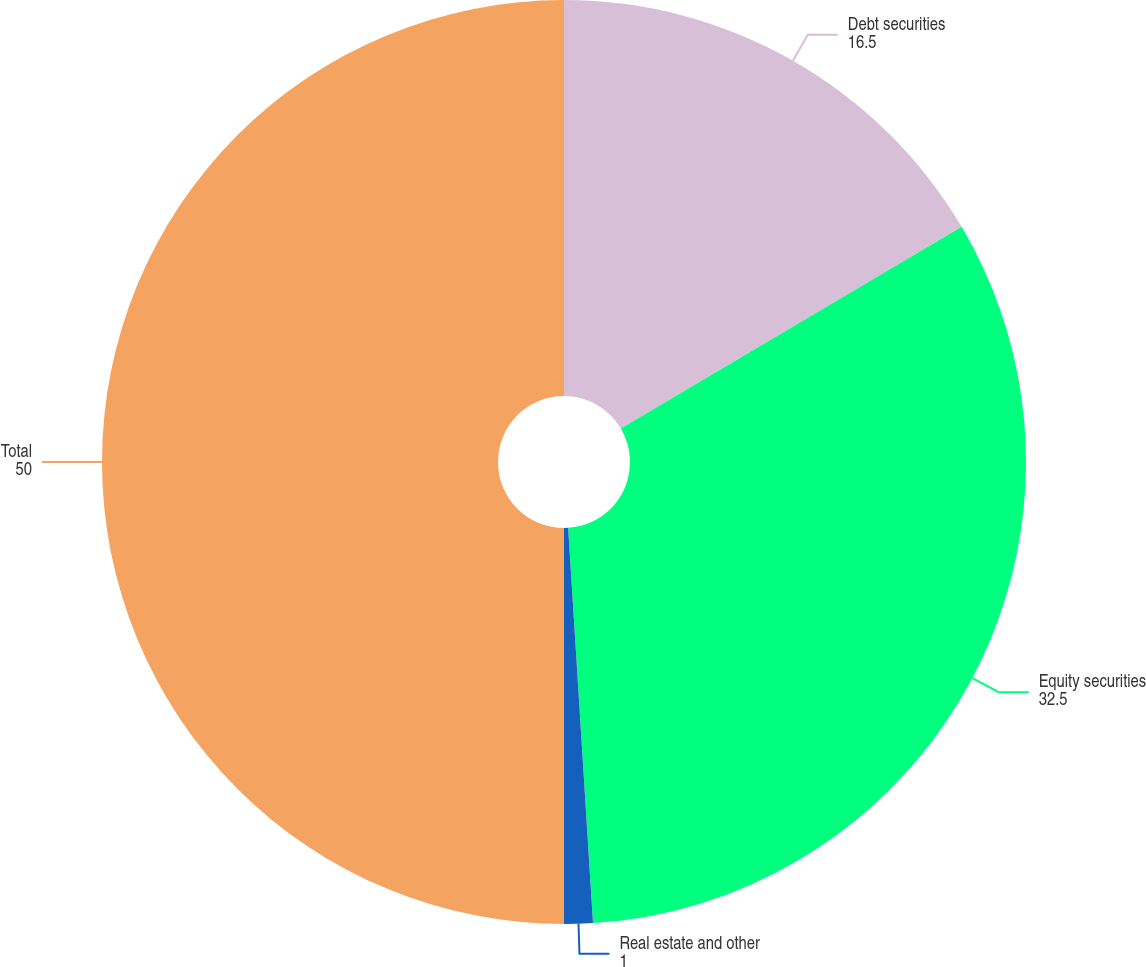Convert chart to OTSL. <chart><loc_0><loc_0><loc_500><loc_500><pie_chart><fcel>Debt securities<fcel>Equity securities<fcel>Real estate and other<fcel>Total<nl><fcel>16.5%<fcel>32.5%<fcel>1.0%<fcel>50.0%<nl></chart> 